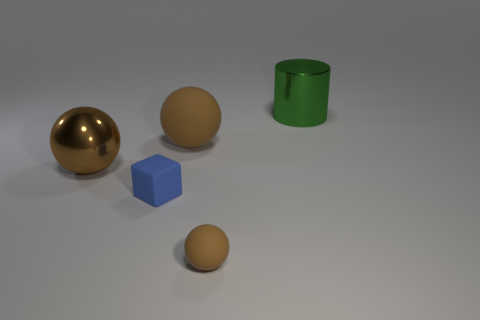The object left of the tiny cube is what color?
Your answer should be compact. Brown. How many other things are there of the same color as the big matte sphere?
Provide a succinct answer. 2. Does the metallic thing that is to the left of the green metal cylinder have the same size as the small brown rubber object?
Your response must be concise. No. There is a green thing; how many metal cylinders are in front of it?
Offer a terse response. 0. Are there any blue cubes of the same size as the metal cylinder?
Offer a very short reply. No. Is the small rubber block the same color as the small matte sphere?
Offer a very short reply. No. What color is the big sphere that is to the left of the tiny object that is on the left side of the large matte sphere?
Provide a short and direct response. Brown. What number of things are both behind the tiny blue thing and right of the large rubber ball?
Keep it short and to the point. 1. How many brown rubber objects have the same shape as the tiny blue thing?
Offer a terse response. 0. Are the small blue block and the tiny brown object made of the same material?
Offer a terse response. Yes. 